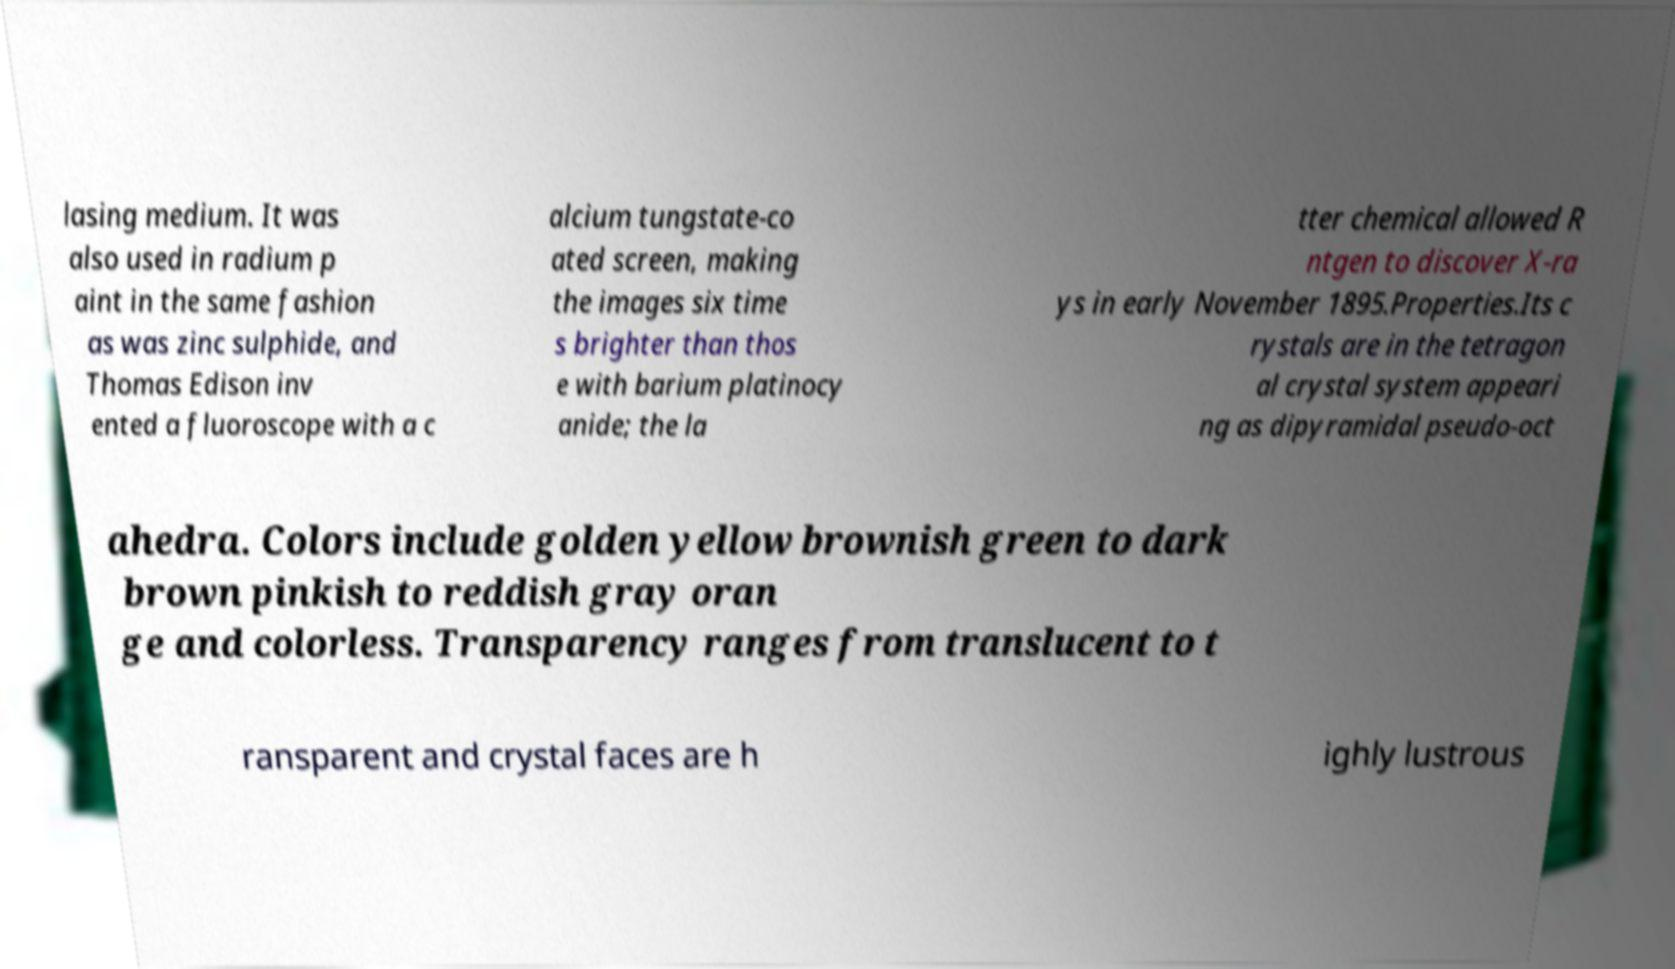Can you read and provide the text displayed in the image?This photo seems to have some interesting text. Can you extract and type it out for me? lasing medium. It was also used in radium p aint in the same fashion as was zinc sulphide, and Thomas Edison inv ented a fluoroscope with a c alcium tungstate-co ated screen, making the images six time s brighter than thos e with barium platinocy anide; the la tter chemical allowed R ntgen to discover X-ra ys in early November 1895.Properties.Its c rystals are in the tetragon al crystal system appeari ng as dipyramidal pseudo-oct ahedra. Colors include golden yellow brownish green to dark brown pinkish to reddish gray oran ge and colorless. Transparency ranges from translucent to t ransparent and crystal faces are h ighly lustrous 